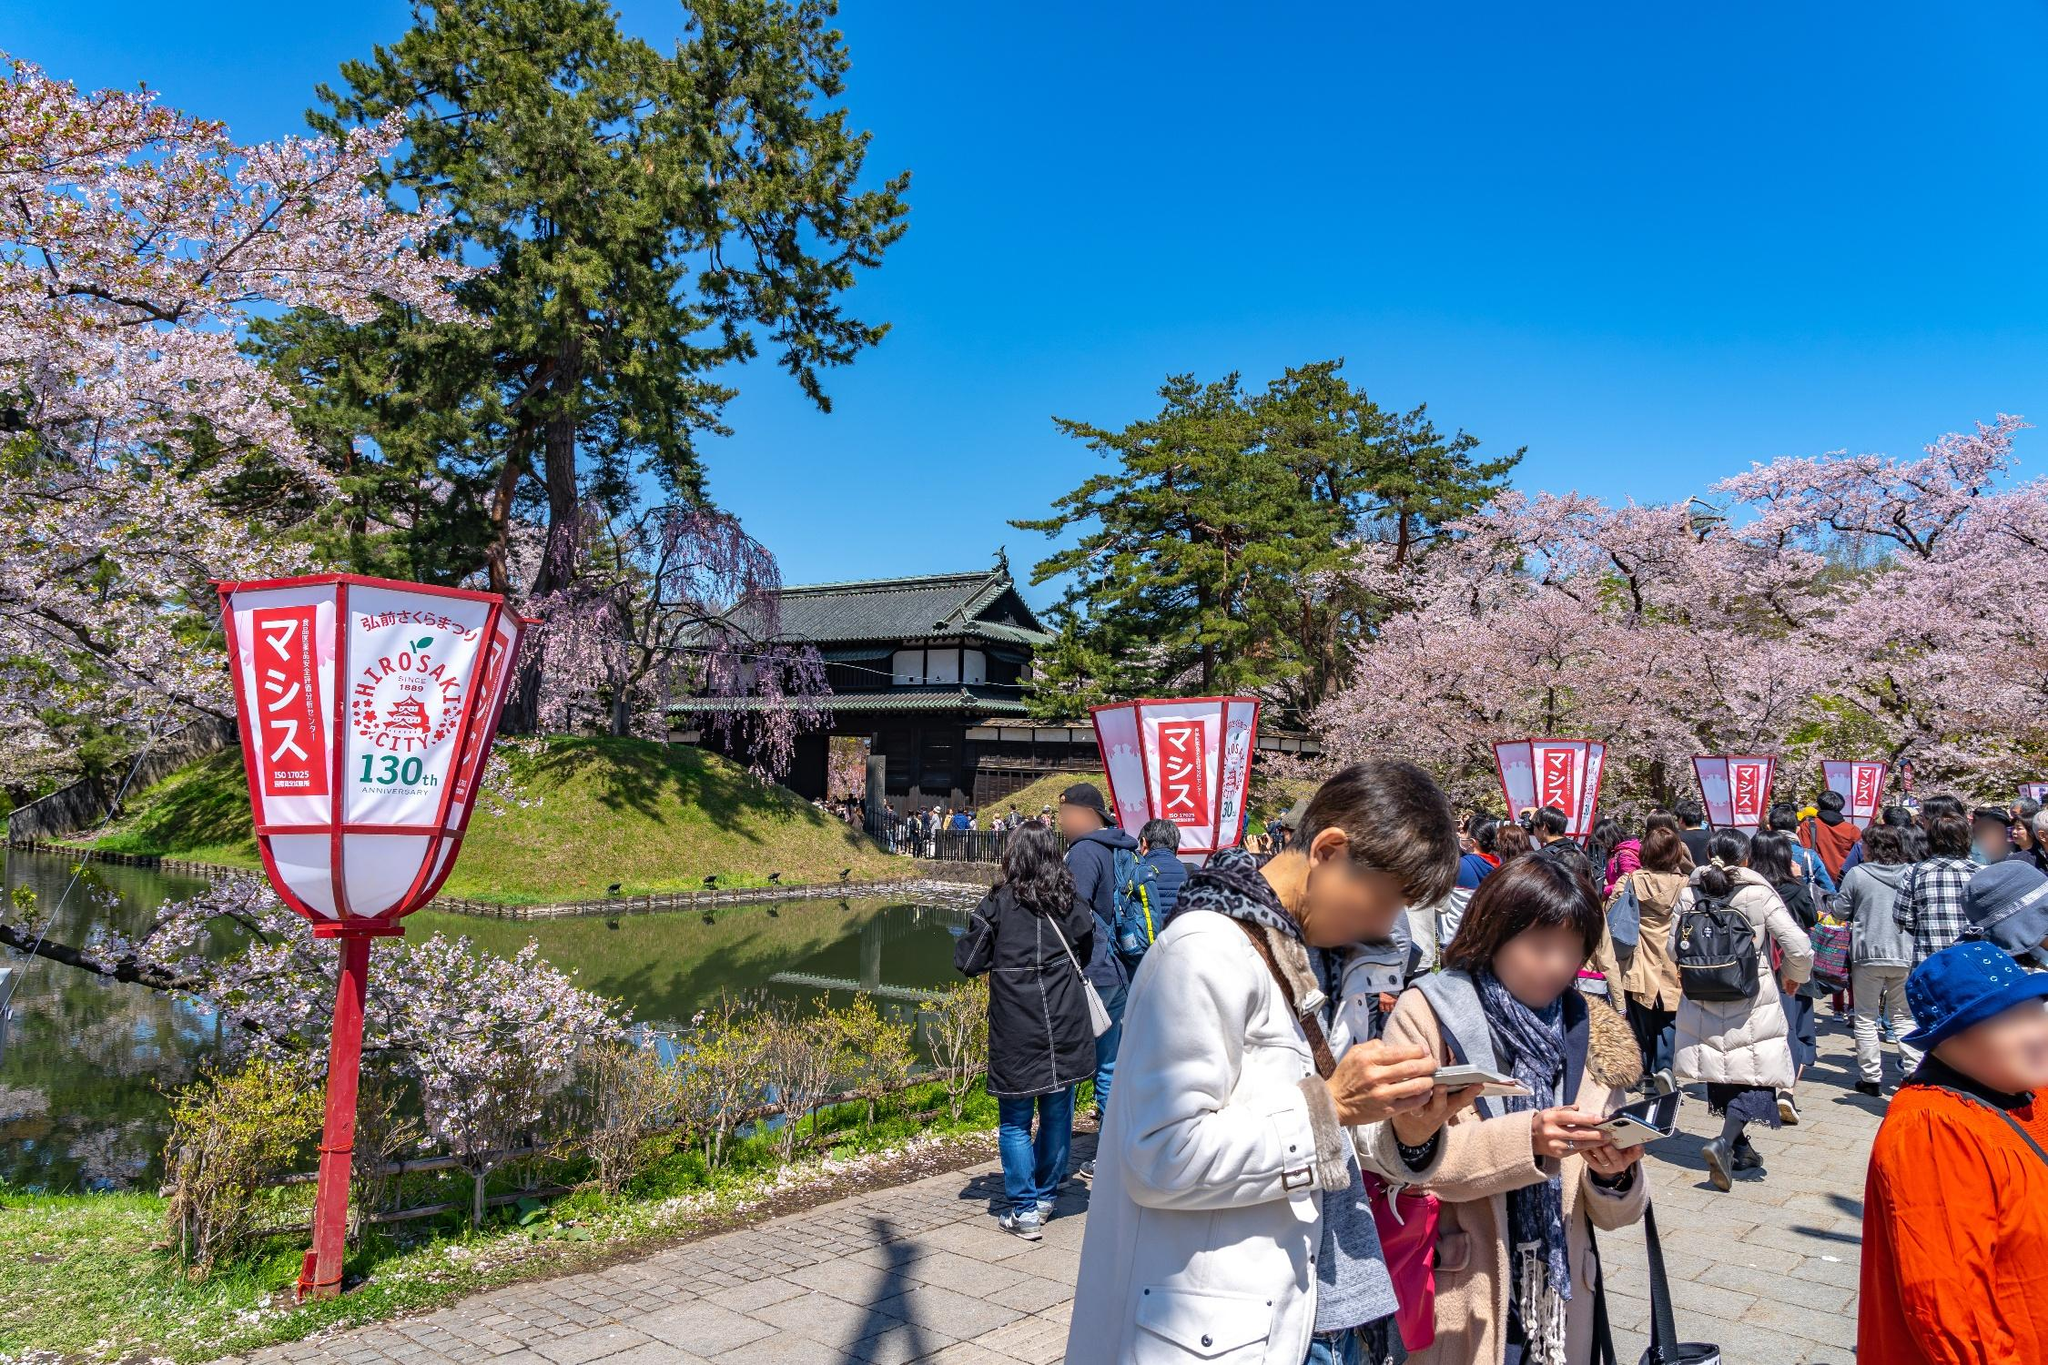Imagine you are a blossom petal. Describe your journey through this festival. As a delicate cherry blossom petal, I begin my journey high in the branches, bathed in sunlight and gently swaying with the breeze. Suddenly, a gust of wind detaches me, and I float gracefully downward, spinning slowly as I descend. Below, I see the excited faces of festival-goers, their cameras capturing every moment. I sail past colorful lanterns and land briefly on a young girl’s hat, then a slight shift sends me drifting onto the surface of the shimmering moat. Botanical artists lean over the edges, trying to catch my beauty on their canvases, while laughter and music surround me. Finally, I settle onto the peaceful water, joining countless other petals, creating a soft, pink blanket that dances on the ripples. 